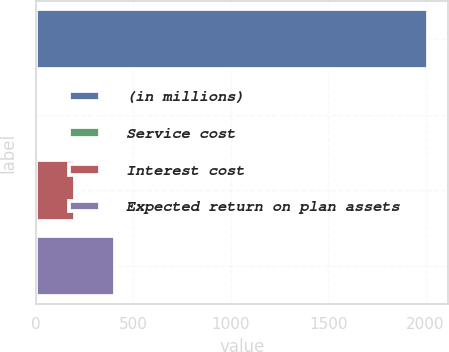Convert chart to OTSL. <chart><loc_0><loc_0><loc_500><loc_500><bar_chart><fcel>(in millions)<fcel>Service cost<fcel>Interest cost<fcel>Expected return on plan assets<nl><fcel>2014<fcel>2<fcel>203.2<fcel>404.4<nl></chart> 